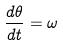Convert formula to latex. <formula><loc_0><loc_0><loc_500><loc_500>\frac { d \theta } { d t } = \omega</formula> 